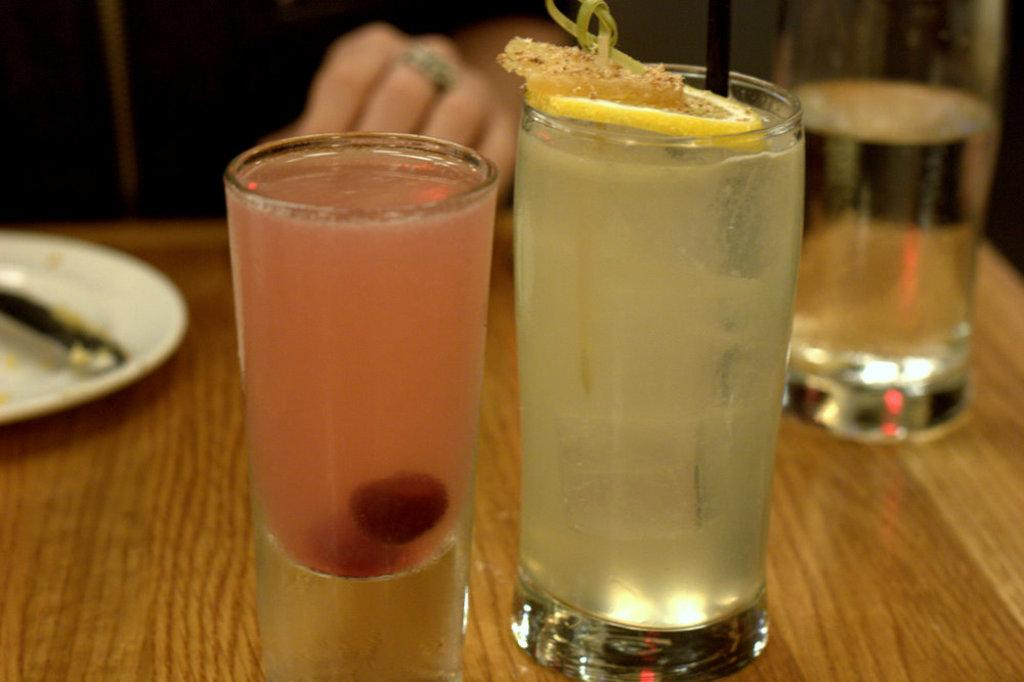What objects are visible on the table in the image? There are glasses and a plate visible on the table in the image. What might be used for drinking or eating in the image? The glasses and plate are likely used for drinking or eating. Where is the human seated in the image? The human is seated at the table in the image. What type of fruit is being peeled by the monkey in the image? There is no monkey or fruit present in the image; it only features glasses, a plate, and a seated human. 